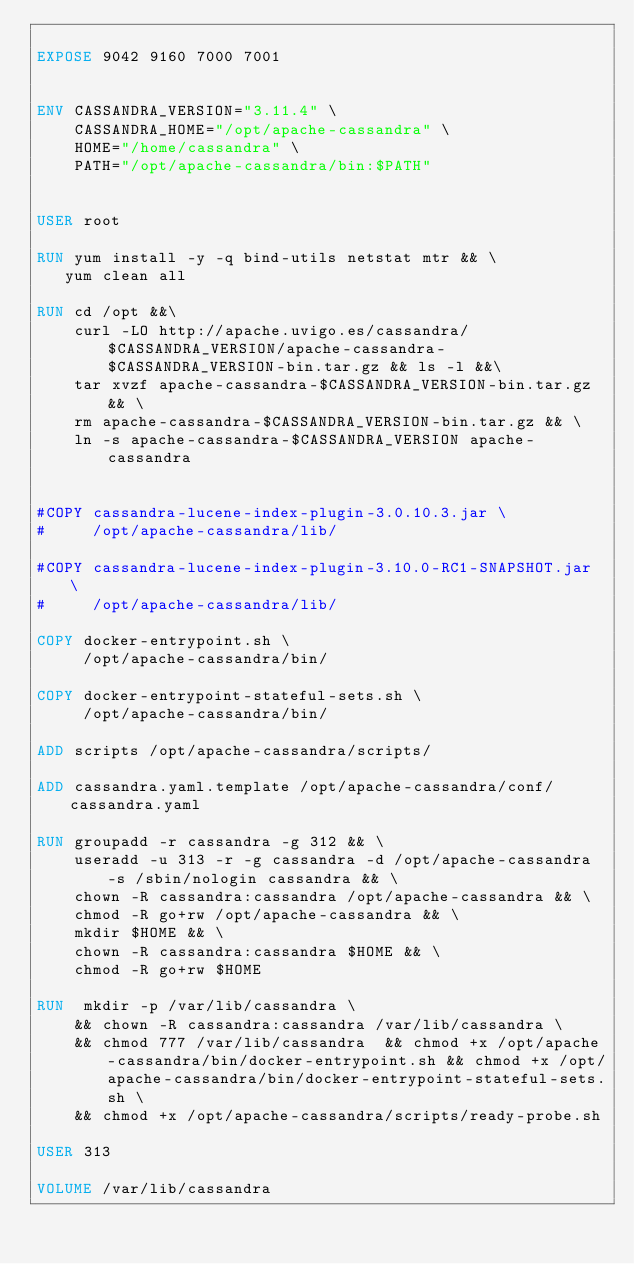<code> <loc_0><loc_0><loc_500><loc_500><_Dockerfile_>
EXPOSE 9042 9160 7000 7001


ENV CASSANDRA_VERSION="3.11.4" \
    CASSANDRA_HOME="/opt/apache-cassandra" \
    HOME="/home/cassandra" \
    PATH="/opt/apache-cassandra/bin:$PATH" 


USER root

RUN yum install -y -q bind-utils netstat mtr && \
   yum clean all

RUN cd /opt &&\
	curl -LO http://apache.uvigo.es/cassandra/$CASSANDRA_VERSION/apache-cassandra-$CASSANDRA_VERSION-bin.tar.gz && ls -l &&\ 
    tar xvzf apache-cassandra-$CASSANDRA_VERSION-bin.tar.gz && \
    rm apache-cassandra-$CASSANDRA_VERSION-bin.tar.gz && \
    ln -s apache-cassandra-$CASSANDRA_VERSION apache-cassandra


#COPY cassandra-lucene-index-plugin-3.0.10.3.jar \
#     /opt/apache-cassandra/lib/

#COPY cassandra-lucene-index-plugin-3.10.0-RC1-SNAPSHOT.jar \
#     /opt/apache-cassandra/lib/     

COPY docker-entrypoint.sh \
     /opt/apache-cassandra/bin/

COPY docker-entrypoint-stateful-sets.sh \
     /opt/apache-cassandra/bin/

ADD scripts /opt/apache-cassandra/scripts/

ADD cassandra.yaml.template /opt/apache-cassandra/conf/cassandra.yaml

RUN groupadd -r cassandra -g 312 && \
    useradd -u 313 -r -g cassandra -d /opt/apache-cassandra -s /sbin/nologin cassandra && \
    chown -R cassandra:cassandra /opt/apache-cassandra && \
    chmod -R go+rw /opt/apache-cassandra && \
    mkdir $HOME && \
    chown -R cassandra:cassandra $HOME && \
    chmod -R go+rw $HOME

RUN  mkdir -p /var/lib/cassandra \
	&& chown -R cassandra:cassandra /var/lib/cassandra \
	&& chmod 777 /var/lib/cassandra  && chmod +x /opt/apache-cassandra/bin/docker-entrypoint.sh && chmod +x /opt/apache-cassandra/bin/docker-entrypoint-stateful-sets.sh \
	&& chmod +x /opt/apache-cassandra/scripts/ready-probe.sh

USER 313	

VOLUME /var/lib/cassandra


</code> 